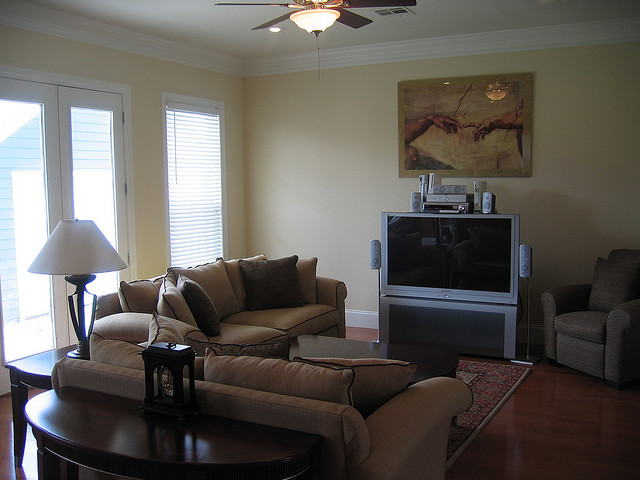<image>Why is the television off? I don't know why the television is off. There can be several reasons such as nobody is watching or the room is empty. Why is the television off? I am not sure why the television is off. It can be because nobody is watching, there is no one there, or nothing to watch. 